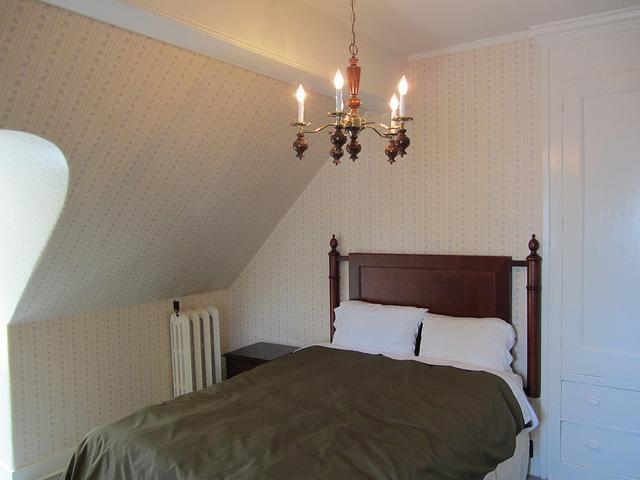Is the sidewall too low?
Concise answer only. Yes. Do the walls have wallpaper?
Concise answer only. Yes. How many pillows?
Short answer required. 2. Is this room big?
Concise answer only. No. Is the bedspread white?
Give a very brief answer. No. What size is the bed?
Quick response, please. Twin. How many pillows are there?
Keep it brief. 2. Is the bed made?
Quick response, please. Yes. 